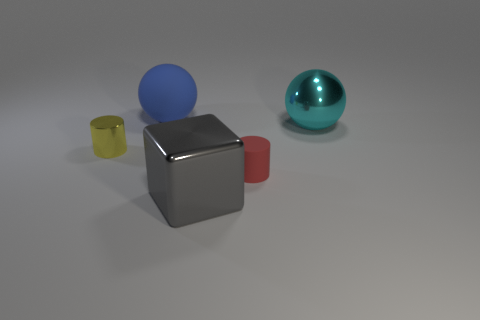Is there anything else that has the same color as the metallic block?
Provide a short and direct response. No. Are there any large yellow metal things of the same shape as the large gray object?
Your answer should be compact. No. Does the small object right of the big matte object have the same material as the tiny object that is on the left side of the matte cylinder?
Provide a short and direct response. No. What number of large gray blocks have the same material as the blue object?
Your answer should be very brief. 0. What color is the large metallic sphere?
Keep it short and to the point. Cyan. Do the matte object behind the red matte object and the rubber object that is in front of the cyan sphere have the same shape?
Keep it short and to the point. No. There is a metallic thing that is behind the metal cylinder; what color is it?
Make the answer very short. Cyan. Is the number of tiny metal things that are in front of the small red matte thing less than the number of tiny shiny things in front of the yellow object?
Offer a terse response. No. How many other things are there of the same material as the small red cylinder?
Offer a terse response. 1. Do the cyan ball and the gray block have the same material?
Provide a short and direct response. Yes. 